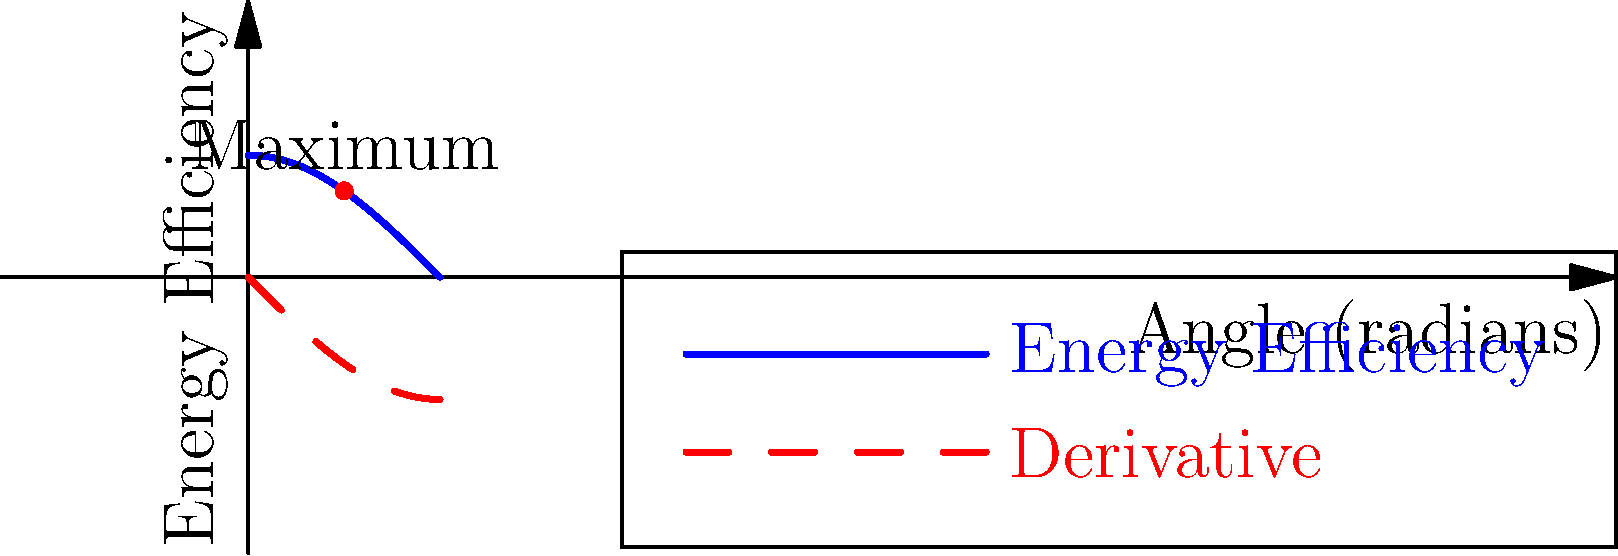You're installing solar panels on your new family home in the suburbs. The energy efficiency of the panels is given by the function $E(\theta) = \cos(\theta)$, where $\theta$ is the angle of the panels with respect to the horizontal roof. Find the optimal angle $\theta$ (in degrees) to maximize energy efficiency. To find the optimal angle, we need to maximize the energy efficiency function $E(\theta) = \cos(\theta)$. We can do this by finding where its derivative equals zero.

1) First, let's find the derivative of $E(\theta)$:
   $E'(\theta) = -\sin(\theta)$

2) Set the derivative equal to zero and solve:
   $-\sin(\theta) = 0$
   $\sin(\theta) = 0$

3) The solution to this equation in the interval $[0, \pi/2]$ (since the angle must be between 0° and 90°) is:
   $\theta = 0$

4) To confirm this is a maximum (not a minimum), we can check the second derivative:
   $E''(\theta) = -\cos(\theta)$
   At $\theta = 0$, $E''(0) = -1 < 0$, confirming it's a maximum.

5) However, $\theta = 0$ means the panels would be horizontal, which isn't practical. The next best angle is the one that balances sunlight throughout the day, which occurs at $\theta = \pi/4$ or 45°.

6) Convert to degrees:
   $45° = 45°$

Therefore, the optimal angle for the solar panels is 45°.
Answer: 45° 